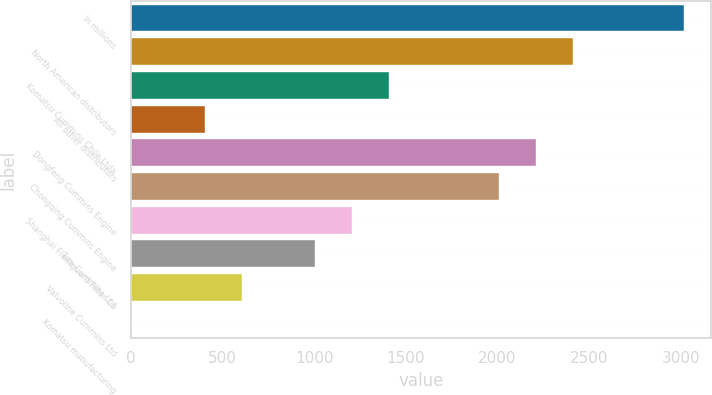Convert chart. <chart><loc_0><loc_0><loc_500><loc_500><bar_chart><fcel>In millions<fcel>North American distributors<fcel>Komatsu Cummins Chile Ltda<fcel>All other distributors<fcel>Dongfeng Cummins Engine<fcel>Chongqing Cummins Engine<fcel>Shanghai Fleetguard Filter Co<fcel>Tata Cummins Ltd<fcel>Valvoline Cummins Ltd<fcel>Komatsu manufacturing<nl><fcel>3015<fcel>2412.6<fcel>1408.6<fcel>404.6<fcel>2211.8<fcel>2011<fcel>1207.8<fcel>1007<fcel>605.4<fcel>3<nl></chart> 